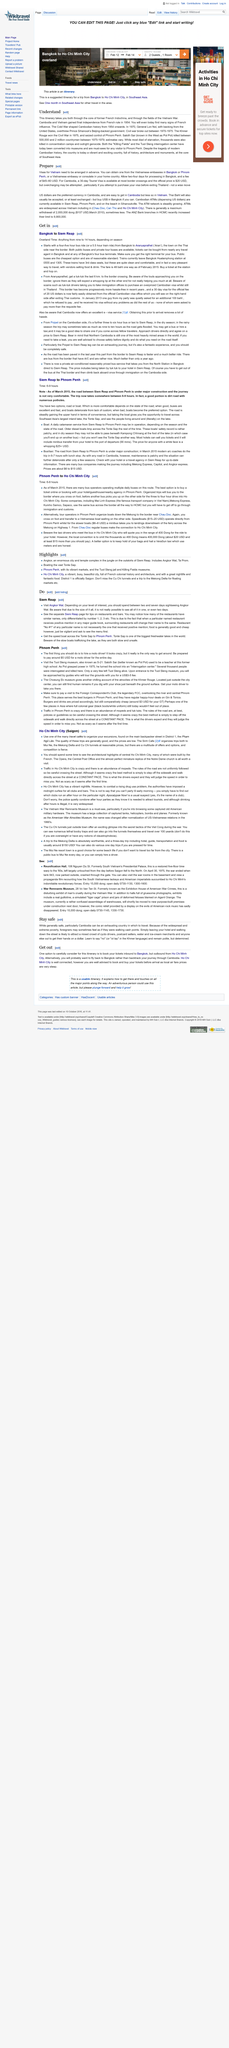Draw attention to some important aspects in this diagram. Yes, visas for Vietnam must be arranged in advance. In the Khmer language, the word for 'no' is 'ot tay'. In 1954, Cambodia and Vietnam gained their final independence from foreign rule. I am looking for information on the best city to fly from in Cambodia, specifically Ho Chi Minh City. Can you provide me with any relevant details or recommendations? Cambodia is safe for tourists. 